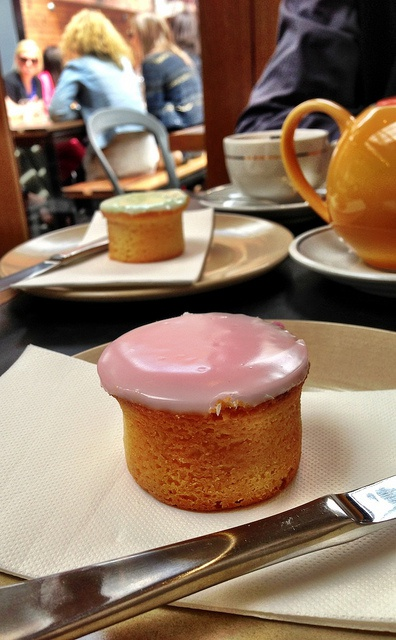Describe the objects in this image and their specific colors. I can see dining table in darkgray, beige, black, brown, and tan tones, cake in darkgray, lightpink, brown, and maroon tones, knife in darkgray, maroon, gray, black, and white tones, people in darkgray, black, gray, and maroon tones, and dining table in darkgray, black, maroon, and tan tones in this image. 